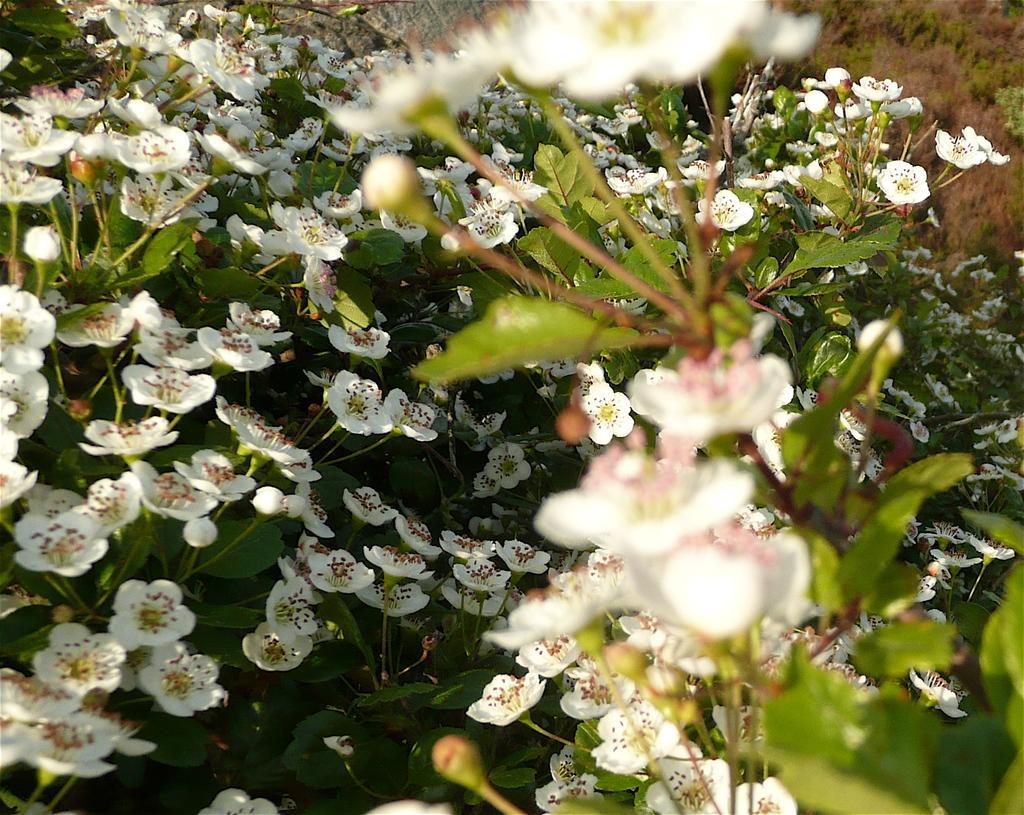In one or two sentences, can you explain what this image depicts? In this image there are white flowers on top of the plant. 